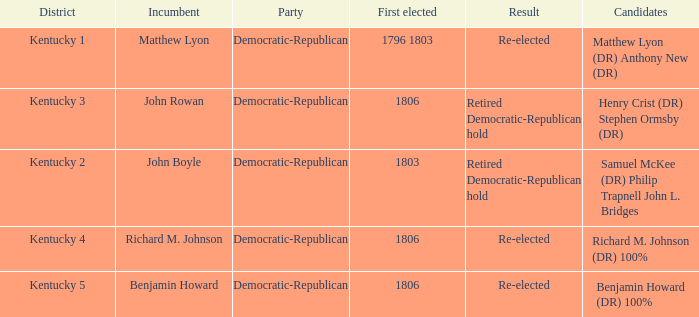Name the first elected for kentucky 3 1806.0. Could you parse the entire table? {'header': ['District', 'Incumbent', 'Party', 'First elected', 'Result', 'Candidates'], 'rows': [['Kentucky 1', 'Matthew Lyon', 'Democratic-Republican', '1796 1803', 'Re-elected', 'Matthew Lyon (DR) Anthony New (DR)'], ['Kentucky 3', 'John Rowan', 'Democratic-Republican', '1806', 'Retired Democratic-Republican hold', 'Henry Crist (DR) Stephen Ormsby (DR)'], ['Kentucky 2', 'John Boyle', 'Democratic-Republican', '1803', 'Retired Democratic-Republican hold', 'Samuel McKee (DR) Philip Trapnell John L. Bridges'], ['Kentucky 4', 'Richard M. Johnson', 'Democratic-Republican', '1806', 'Re-elected', 'Richard M. Johnson (DR) 100%'], ['Kentucky 5', 'Benjamin Howard', 'Democratic-Republican', '1806', 'Re-elected', 'Benjamin Howard (DR) 100%']]} 